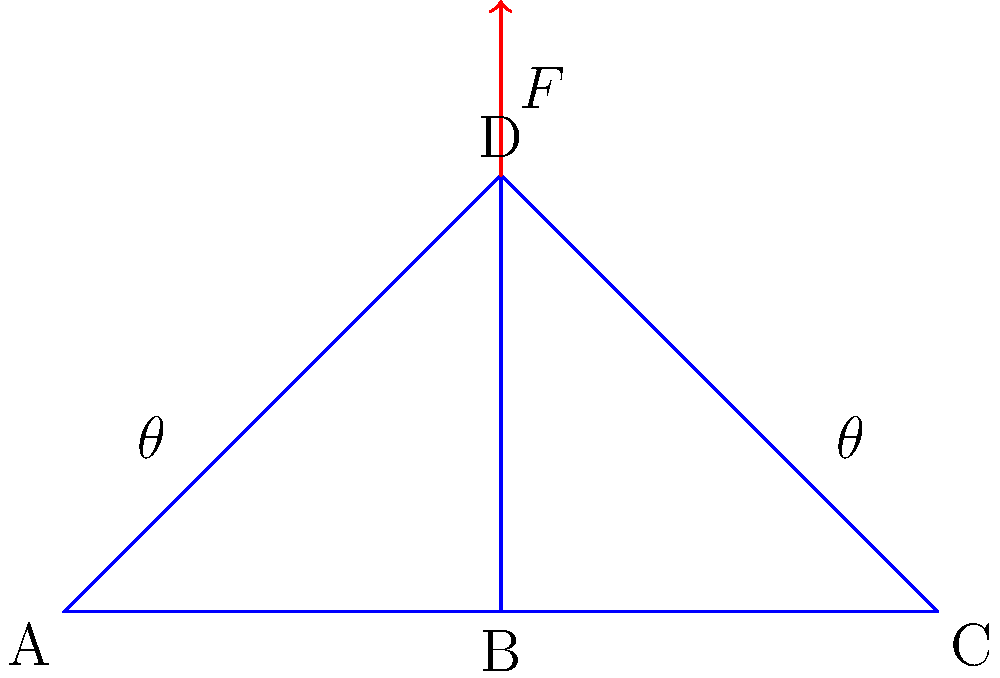During World War I, a truss bridge was designed to support heavy military vehicles. The truss shown above is subjected to a vertical load $F$ at point D. If the angle $\theta$ is 30°, what is the ratio of the compressive force in member BD to the tensile force in member AB? To solve this problem, we'll follow these steps:

1) First, we need to understand that in a truss, forces are transmitted axially through the members.

2) We can use the method of joints to analyze the forces at joint D.

3) At joint D, we have three forces in equilibrium: the external load $F$ and the internal forces in members AD and BD.

4) Due to symmetry, the forces in AD and CD are equal. Let's call the force in BD as $F_{BD}$ and the force in AD (and CD) as $F_{AD}$.

5) Writing the equilibrium equations for joint D:
   Vertical: $F = 2F_{AD}\sin\theta$
   Horizontal: $F_{BD} = 2F_{AD}\cos\theta$

6) From the vertical equation: $F_{AD} = \frac{F}{2\sin\theta}$

7) Substituting this into the horizontal equation:
   $F_{BD} = 2(\frac{F}{2\sin\theta})\cos\theta = F\cot\theta$

8) Now, for member AB, the force is simply $F_{AB} = F_{AD} = \frac{F}{2\sin\theta}$

9) The ratio of $F_{BD}$ to $F_{AB}$ is:
   $$\frac{F_{BD}}{F_{AB}} = \frac{F\cot\theta}{\frac{F}{2\sin\theta}} = 2\cos\theta$$

10) Given $\theta = 30°$, we can calculate:
    $$\frac{F_{BD}}{F_{AB}} = 2\cos(30°) = 2 \cdot \frac{\sqrt{3}}{2} = \sqrt{3}$$

Therefore, the ratio of the compressive force in BD to the tensile force in AB is $\sqrt{3}$.
Answer: $\sqrt{3}$ 